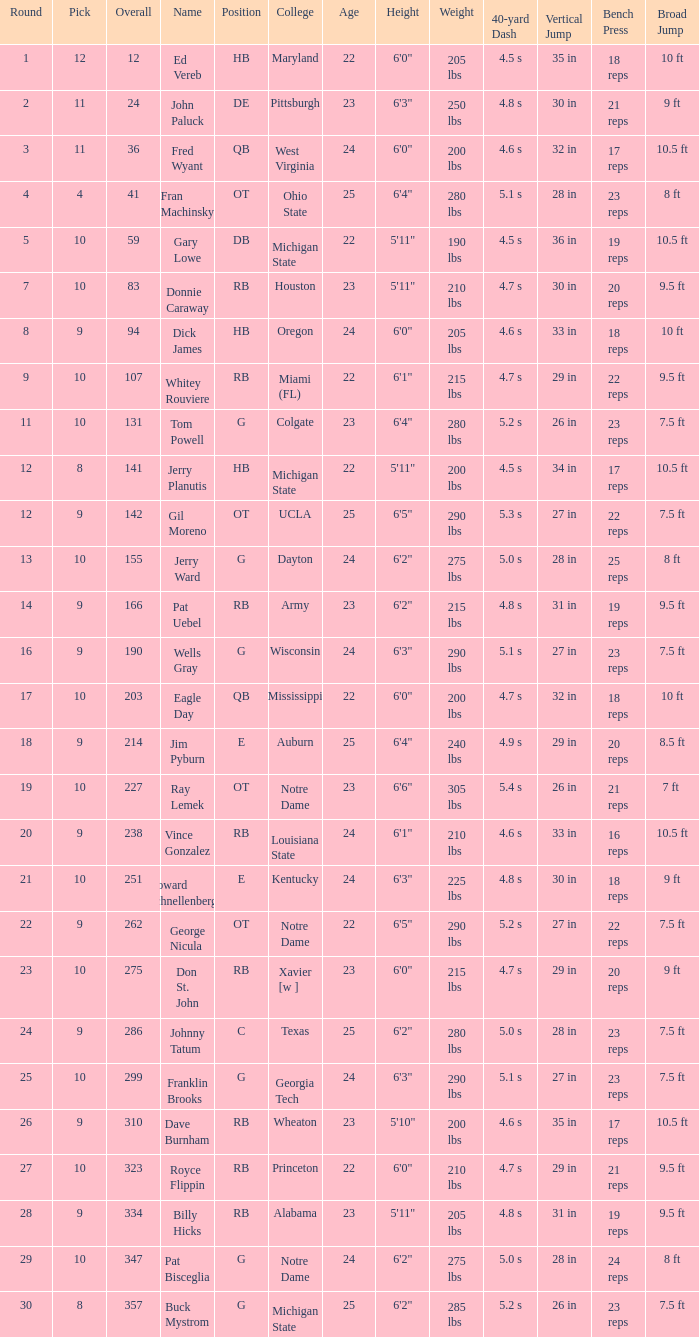What is the overall pick number for a draft pick smaller than 9, named buck mystrom from Michigan State college? 357.0. 